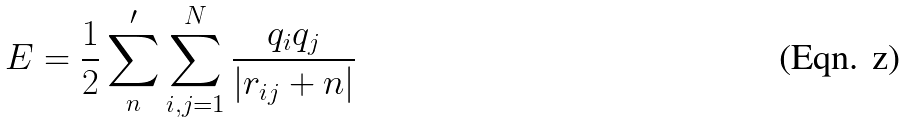<formula> <loc_0><loc_0><loc_500><loc_500>E = \frac { 1 } { 2 } \sum _ { n } ^ { \prime } \sum _ { i , j = 1 } ^ { N } \frac { q _ { i } q _ { j } } { | { r } _ { i j } + { n } | }</formula> 